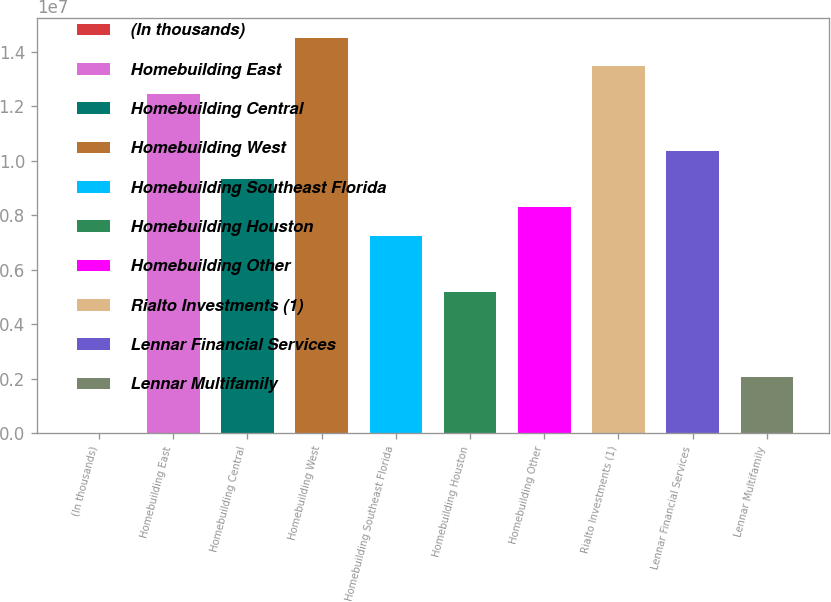<chart> <loc_0><loc_0><loc_500><loc_500><bar_chart><fcel>(In thousands)<fcel>Homebuilding East<fcel>Homebuilding Central<fcel>Homebuilding West<fcel>Homebuilding Southeast Florida<fcel>Homebuilding Houston<fcel>Homebuilding Other<fcel>Rialto Investments (1)<fcel>Lennar Financial Services<fcel>Lennar Multifamily<nl><fcel>2012<fcel>1.24342e+07<fcel>9.32619e+06<fcel>1.45063e+07<fcel>7.25415e+06<fcel>5.18211e+06<fcel>8.29017e+06<fcel>1.34703e+07<fcel>1.03622e+07<fcel>2.07405e+06<nl></chart> 